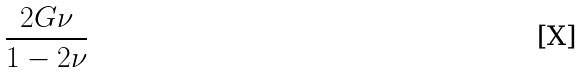Convert formula to latex. <formula><loc_0><loc_0><loc_500><loc_500>\frac { 2 G \nu } { 1 - 2 \nu }</formula> 